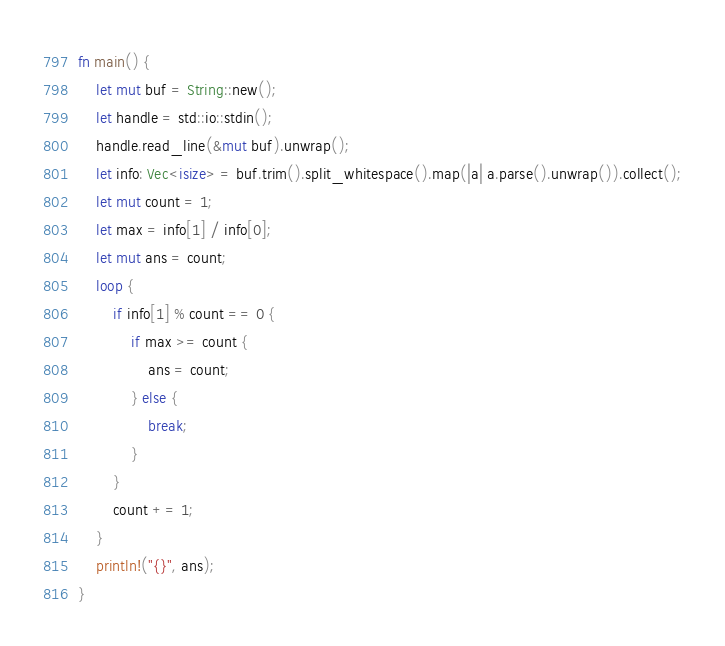Convert code to text. <code><loc_0><loc_0><loc_500><loc_500><_Rust_>fn main() {
    let mut buf = String::new();
    let handle = std::io::stdin();
    handle.read_line(&mut buf).unwrap();
    let info: Vec<isize> = buf.trim().split_whitespace().map(|a| a.parse().unwrap()).collect();
    let mut count = 1;
    let max = info[1] / info[0];
    let mut ans = count;
    loop {
        if info[1] % count == 0 {
            if max >= count {
                ans = count;
            } else {
                break;
            }
        }
        count += 1;
    }
    println!("{}", ans);
}</code> 